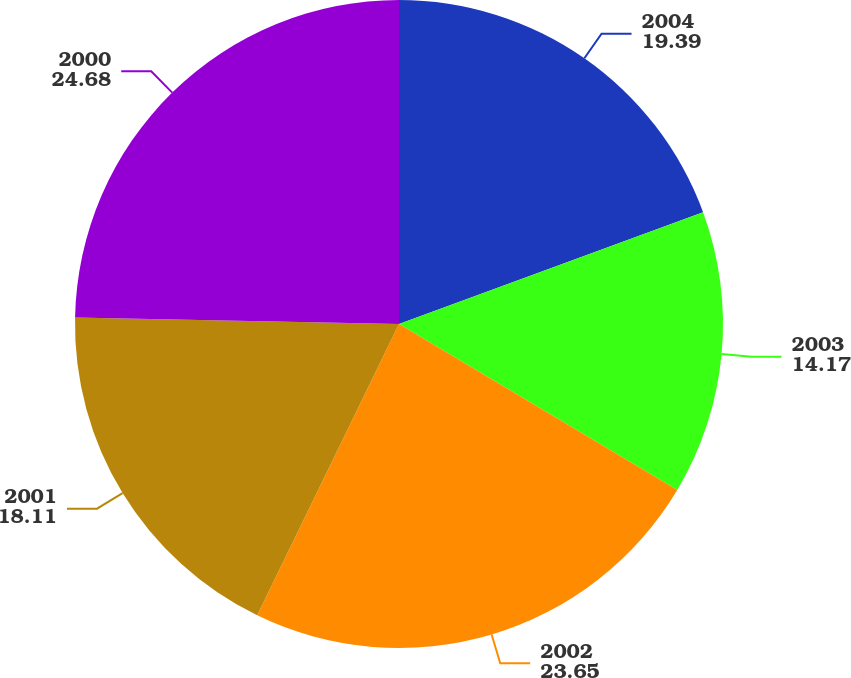<chart> <loc_0><loc_0><loc_500><loc_500><pie_chart><fcel>2004<fcel>2003<fcel>2002<fcel>2001<fcel>2000<nl><fcel>19.39%<fcel>14.17%<fcel>23.65%<fcel>18.11%<fcel>24.68%<nl></chart> 